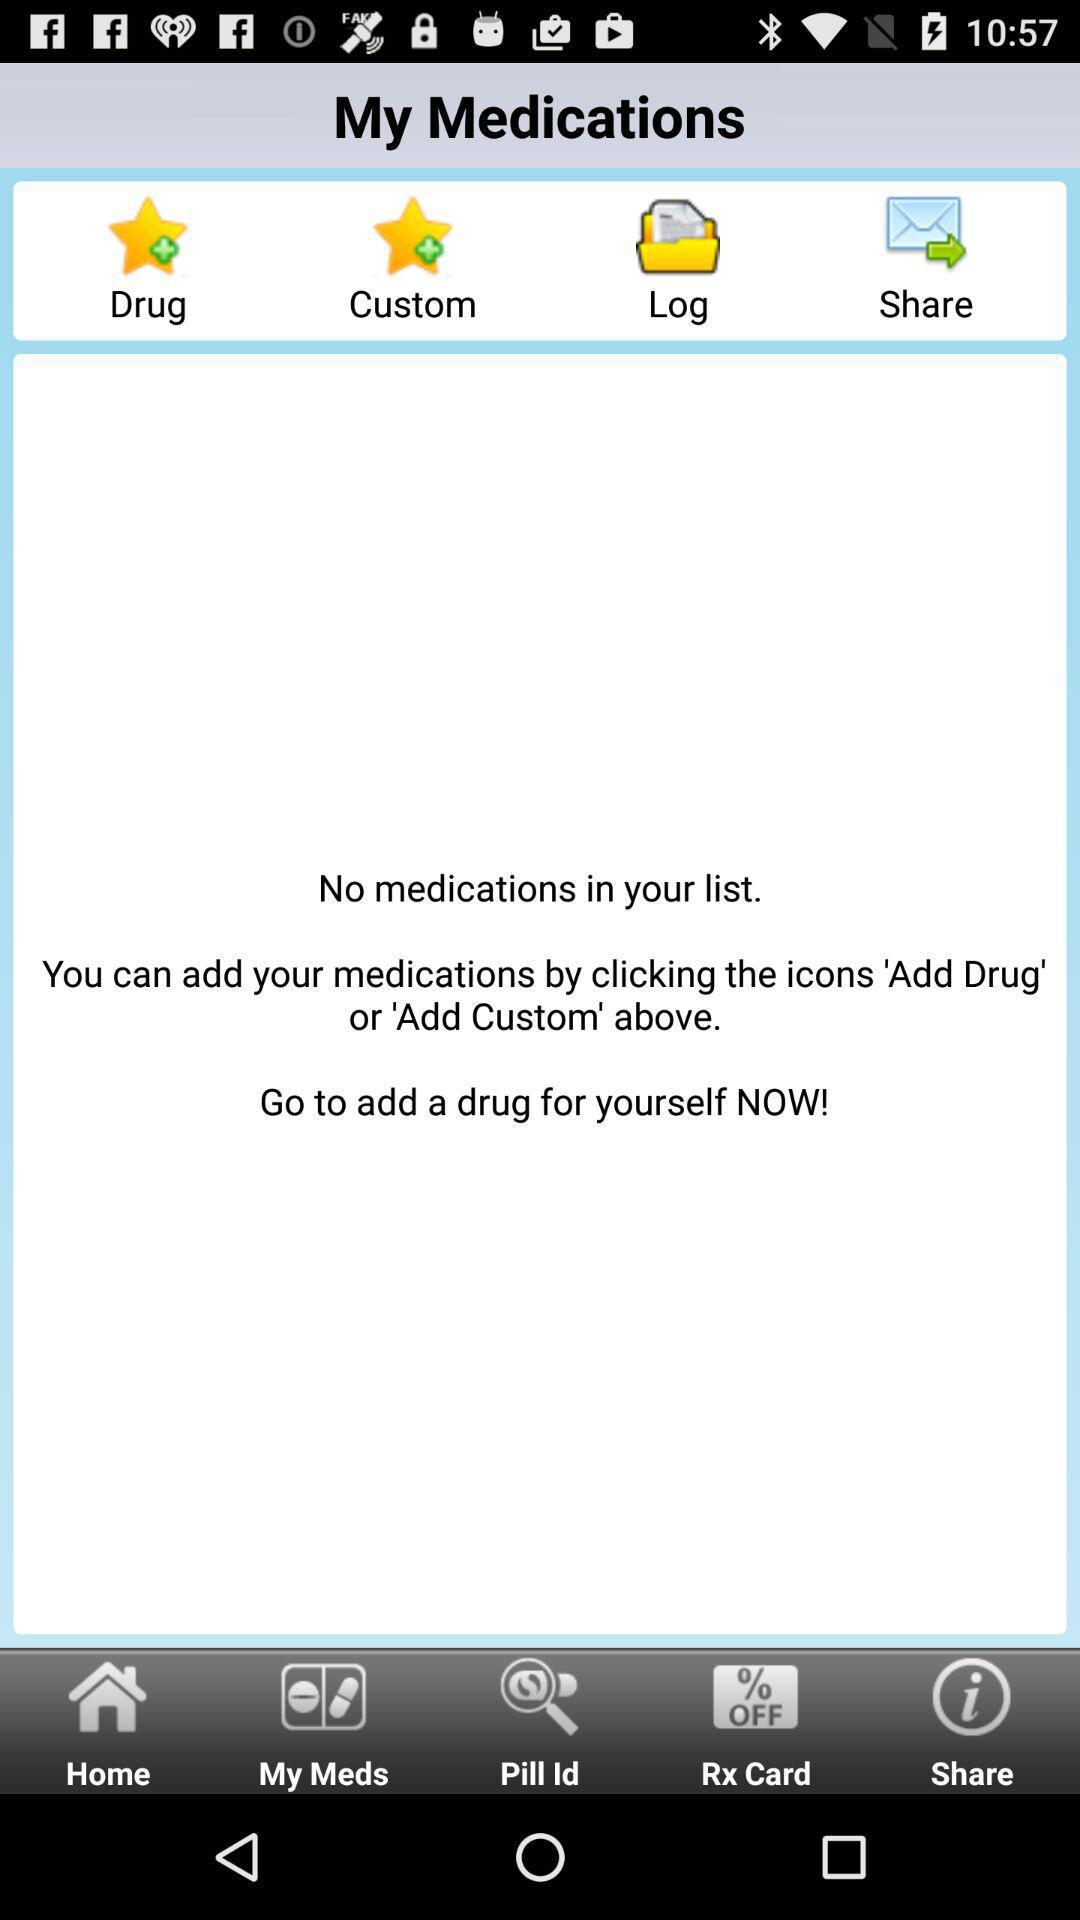Is there any medication? There is no medication. 